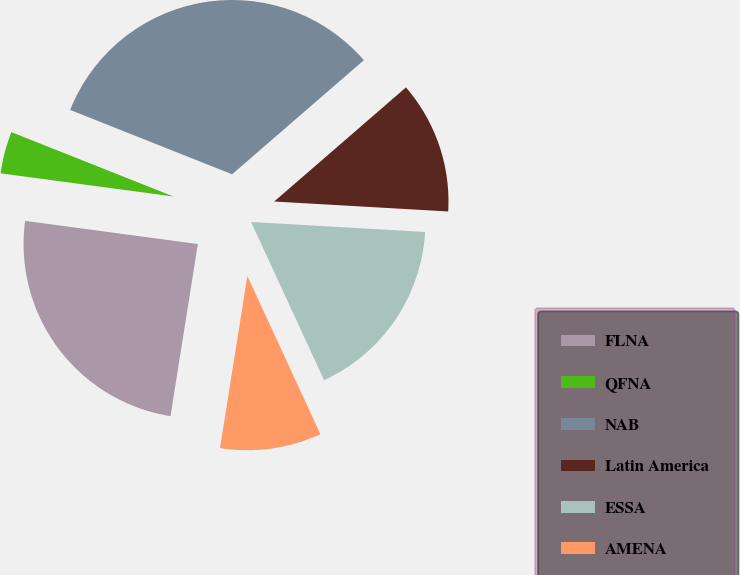<chart> <loc_0><loc_0><loc_500><loc_500><pie_chart><fcel>FLNA<fcel>QFNA<fcel>NAB<fcel>Latin America<fcel>ESSA<fcel>AMENA<nl><fcel>24.61%<fcel>3.9%<fcel>32.62%<fcel>12.27%<fcel>17.21%<fcel>9.39%<nl></chart> 